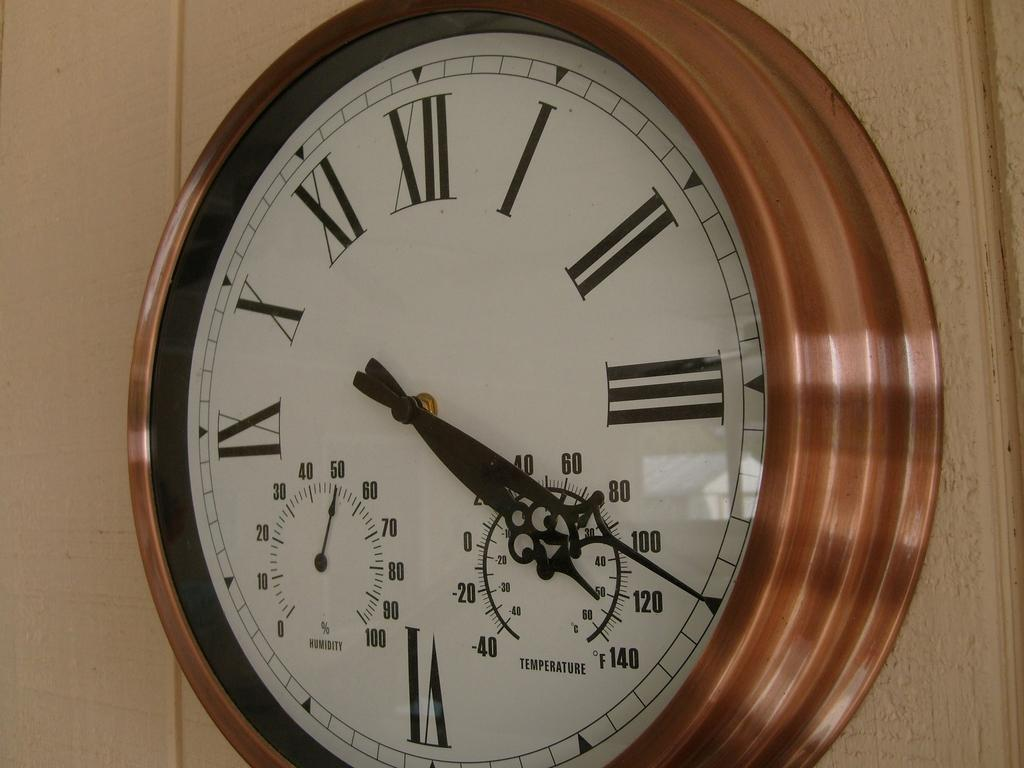Provide a one-sentence caption for the provided image. An ornate wall clock tells the time as 4:20. 